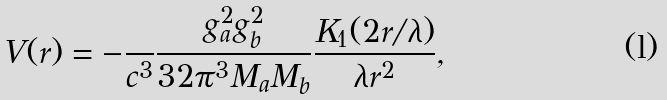<formula> <loc_0><loc_0><loc_500><loc_500>V ( r ) = - \frac { } { c ^ { 3 } } \frac { g _ { a } ^ { 2 } g _ { b } ^ { 2 } } { 3 2 \pi ^ { 3 } M _ { a } M _ { b } } \frac { K _ { 1 } ( 2 r / \lambda ) } { \lambda r ^ { 2 } } ,</formula> 